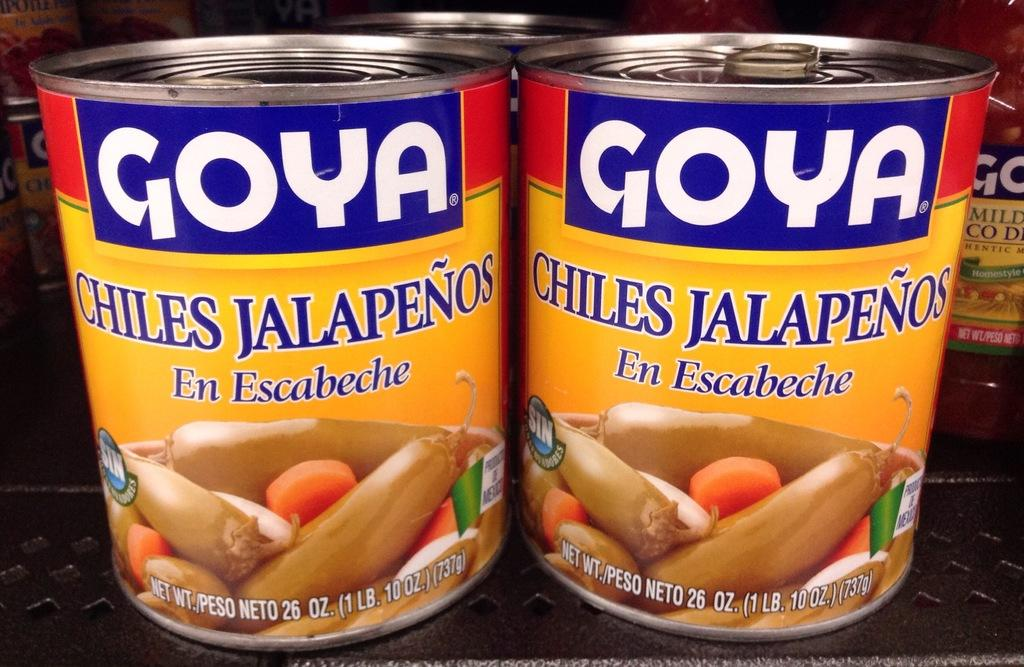What is the main object in the image? There is an object that looks like a rack in the image. What is placed on the rack? There are boxes on the rack. What can be seen on the boxes? The boxes have text and images on them. How many eyes are visible on the boxes in the image? There are no eyes visible on the boxes in the image. What type of jam is stored in the boxes on the rack? There is no jam present in the image; the boxes have text and images on them. 